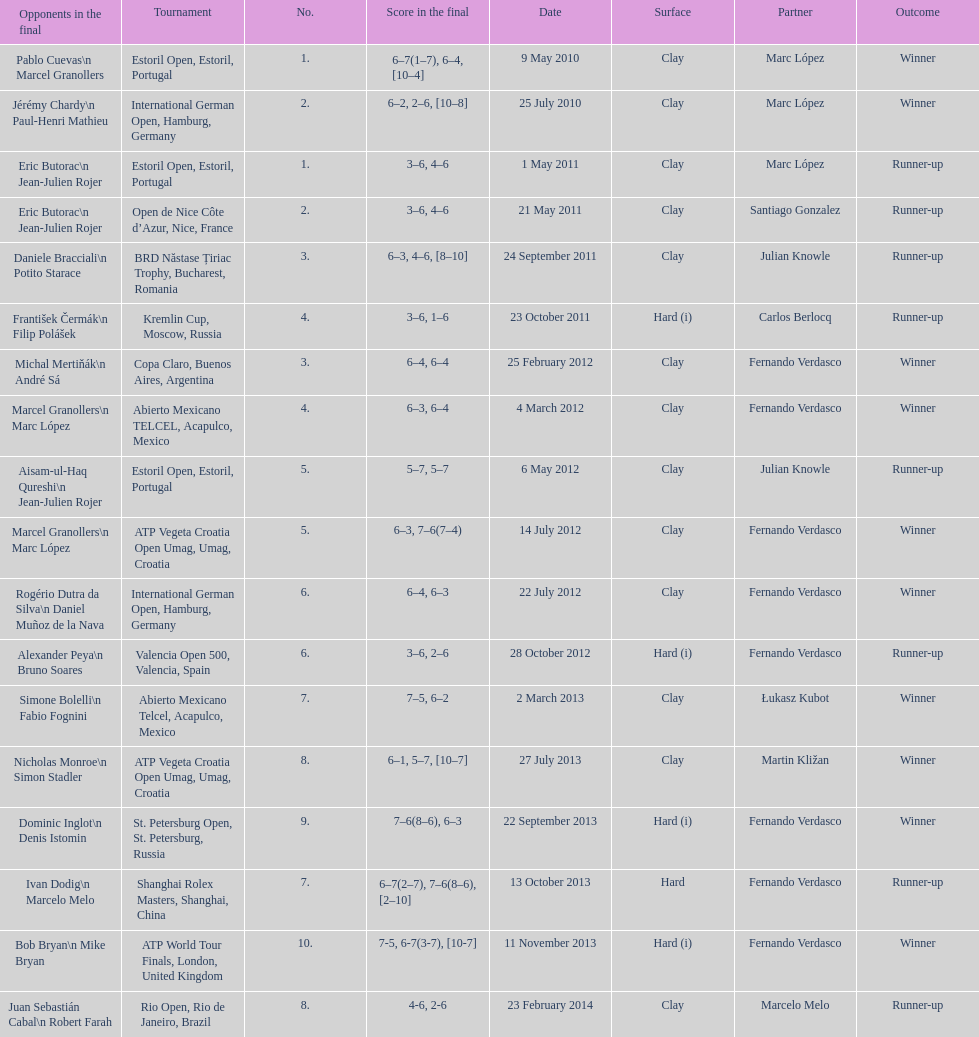How many partners from spain are listed? 2. Write the full table. {'header': ['Opponents in the final', 'Tournament', 'No.', 'Score in the final', 'Date', 'Surface', 'Partner', 'Outcome'], 'rows': [['Pablo Cuevas\\n Marcel Granollers', 'Estoril Open, Estoril, Portugal', '1.', '6–7(1–7), 6–4, [10–4]', '9 May 2010', 'Clay', 'Marc López', 'Winner'], ['Jérémy Chardy\\n Paul-Henri Mathieu', 'International German Open, Hamburg, Germany', '2.', '6–2, 2–6, [10–8]', '25 July 2010', 'Clay', 'Marc López', 'Winner'], ['Eric Butorac\\n Jean-Julien Rojer', 'Estoril Open, Estoril, Portugal', '1.', '3–6, 4–6', '1 May 2011', 'Clay', 'Marc López', 'Runner-up'], ['Eric Butorac\\n Jean-Julien Rojer', 'Open de Nice Côte d’Azur, Nice, France', '2.', '3–6, 4–6', '21 May 2011', 'Clay', 'Santiago Gonzalez', 'Runner-up'], ['Daniele Bracciali\\n Potito Starace', 'BRD Năstase Țiriac Trophy, Bucharest, Romania', '3.', '6–3, 4–6, [8–10]', '24 September 2011', 'Clay', 'Julian Knowle', 'Runner-up'], ['František Čermák\\n Filip Polášek', 'Kremlin Cup, Moscow, Russia', '4.', '3–6, 1–6', '23 October 2011', 'Hard (i)', 'Carlos Berlocq', 'Runner-up'], ['Michal Mertiňák\\n André Sá', 'Copa Claro, Buenos Aires, Argentina', '3.', '6–4, 6–4', '25 February 2012', 'Clay', 'Fernando Verdasco', 'Winner'], ['Marcel Granollers\\n Marc López', 'Abierto Mexicano TELCEL, Acapulco, Mexico', '4.', '6–3, 6–4', '4 March 2012', 'Clay', 'Fernando Verdasco', 'Winner'], ['Aisam-ul-Haq Qureshi\\n Jean-Julien Rojer', 'Estoril Open, Estoril, Portugal', '5.', '5–7, 5–7', '6 May 2012', 'Clay', 'Julian Knowle', 'Runner-up'], ['Marcel Granollers\\n Marc López', 'ATP Vegeta Croatia Open Umag, Umag, Croatia', '5.', '6–3, 7–6(7–4)', '14 July 2012', 'Clay', 'Fernando Verdasco', 'Winner'], ['Rogério Dutra da Silva\\n Daniel Muñoz de la Nava', 'International German Open, Hamburg, Germany', '6.', '6–4, 6–3', '22 July 2012', 'Clay', 'Fernando Verdasco', 'Winner'], ['Alexander Peya\\n Bruno Soares', 'Valencia Open 500, Valencia, Spain', '6.', '3–6, 2–6', '28 October 2012', 'Hard (i)', 'Fernando Verdasco', 'Runner-up'], ['Simone Bolelli\\n Fabio Fognini', 'Abierto Mexicano Telcel, Acapulco, Mexico', '7.', '7–5, 6–2', '2 March 2013', 'Clay', 'Łukasz Kubot', 'Winner'], ['Nicholas Monroe\\n Simon Stadler', 'ATP Vegeta Croatia Open Umag, Umag, Croatia', '8.', '6–1, 5–7, [10–7]', '27 July 2013', 'Clay', 'Martin Kližan', 'Winner'], ['Dominic Inglot\\n Denis Istomin', 'St. Petersburg Open, St. Petersburg, Russia', '9.', '7–6(8–6), 6–3', '22 September 2013', 'Hard (i)', 'Fernando Verdasco', 'Winner'], ['Ivan Dodig\\n Marcelo Melo', 'Shanghai Rolex Masters, Shanghai, China', '7.', '6–7(2–7), 7–6(8–6), [2–10]', '13 October 2013', 'Hard', 'Fernando Verdasco', 'Runner-up'], ['Bob Bryan\\n Mike Bryan', 'ATP World Tour Finals, London, United Kingdom', '10.', '7-5, 6-7(3-7), [10-7]', '11 November 2013', 'Hard (i)', 'Fernando Verdasco', 'Winner'], ['Juan Sebastián Cabal\\n Robert Farah', 'Rio Open, Rio de Janeiro, Brazil', '8.', '4-6, 2-6', '23 February 2014', 'Clay', 'Marcelo Melo', 'Runner-up']]} 